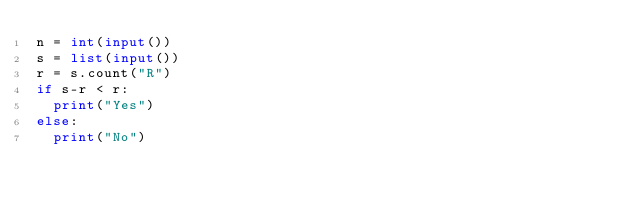Convert code to text. <code><loc_0><loc_0><loc_500><loc_500><_Python_>n = int(input())
s = list(input())
r = s.count("R")
if s-r < r:
  print("Yes")
else:
  print("No")</code> 